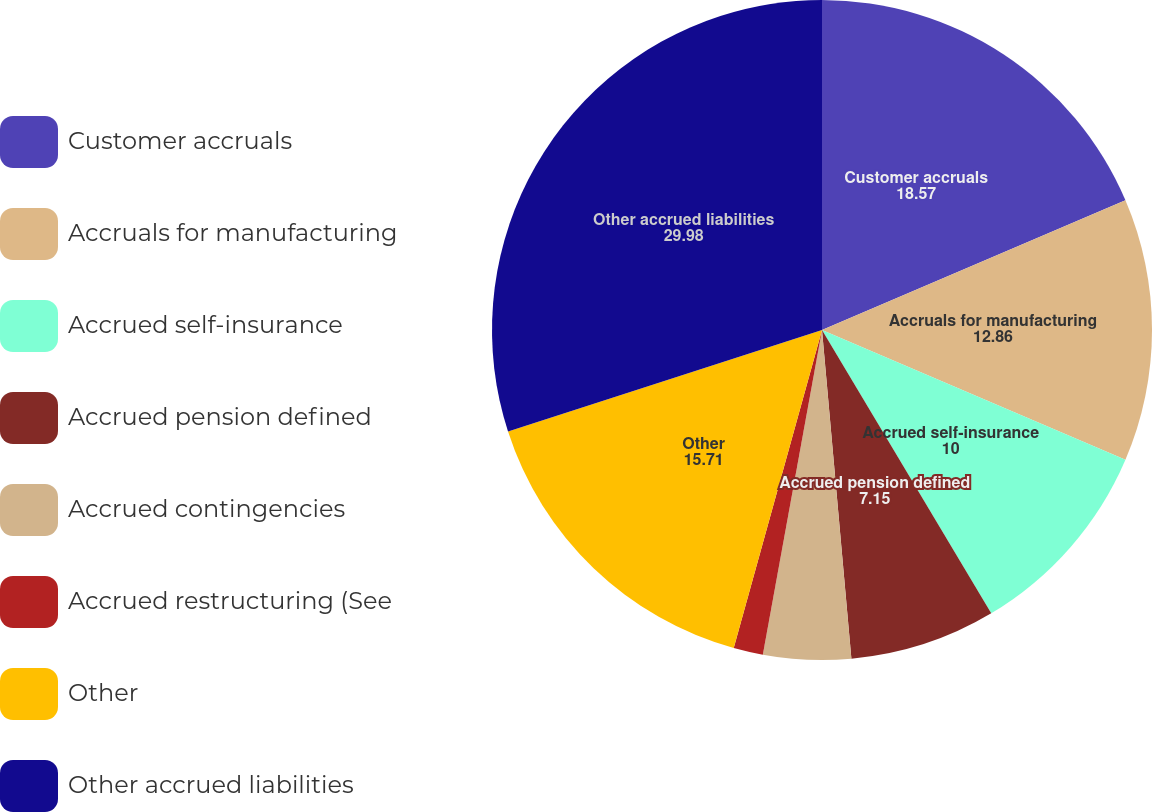Convert chart. <chart><loc_0><loc_0><loc_500><loc_500><pie_chart><fcel>Customer accruals<fcel>Accruals for manufacturing<fcel>Accrued self-insurance<fcel>Accrued pension defined<fcel>Accrued contingencies<fcel>Accrued restructuring (See<fcel>Other<fcel>Other accrued liabilities<nl><fcel>18.57%<fcel>12.86%<fcel>10.0%<fcel>7.15%<fcel>4.29%<fcel>1.44%<fcel>15.71%<fcel>29.98%<nl></chart> 